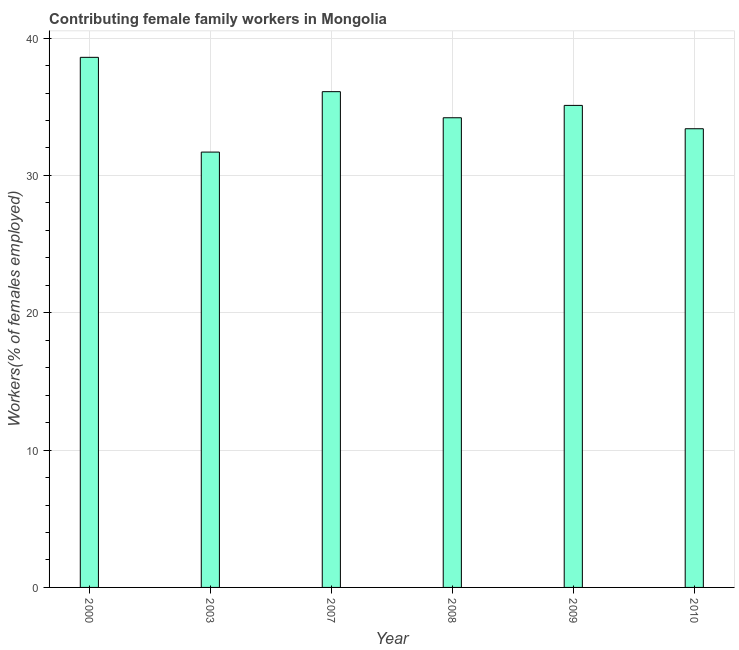Does the graph contain any zero values?
Keep it short and to the point. No. What is the title of the graph?
Provide a short and direct response. Contributing female family workers in Mongolia. What is the label or title of the X-axis?
Give a very brief answer. Year. What is the label or title of the Y-axis?
Make the answer very short. Workers(% of females employed). What is the contributing female family workers in 2007?
Your response must be concise. 36.1. Across all years, what is the maximum contributing female family workers?
Your answer should be compact. 38.6. Across all years, what is the minimum contributing female family workers?
Make the answer very short. 31.7. In which year was the contributing female family workers minimum?
Make the answer very short. 2003. What is the sum of the contributing female family workers?
Ensure brevity in your answer.  209.1. What is the difference between the contributing female family workers in 2003 and 2007?
Provide a succinct answer. -4.4. What is the average contributing female family workers per year?
Provide a short and direct response. 34.85. What is the median contributing female family workers?
Your answer should be very brief. 34.65. In how many years, is the contributing female family workers greater than 20 %?
Provide a short and direct response. 6. Is the difference between the contributing female family workers in 2000 and 2008 greater than the difference between any two years?
Your response must be concise. No. Is the sum of the contributing female family workers in 2003 and 2009 greater than the maximum contributing female family workers across all years?
Make the answer very short. Yes. What is the difference between the highest and the lowest contributing female family workers?
Offer a very short reply. 6.9. Are all the bars in the graph horizontal?
Ensure brevity in your answer.  No. Are the values on the major ticks of Y-axis written in scientific E-notation?
Provide a succinct answer. No. What is the Workers(% of females employed) of 2000?
Make the answer very short. 38.6. What is the Workers(% of females employed) in 2003?
Make the answer very short. 31.7. What is the Workers(% of females employed) of 2007?
Your response must be concise. 36.1. What is the Workers(% of females employed) of 2008?
Offer a very short reply. 34.2. What is the Workers(% of females employed) in 2009?
Your response must be concise. 35.1. What is the Workers(% of females employed) of 2010?
Your response must be concise. 33.4. What is the difference between the Workers(% of females employed) in 2000 and 2009?
Keep it short and to the point. 3.5. What is the difference between the Workers(% of females employed) in 2003 and 2008?
Give a very brief answer. -2.5. What is the difference between the Workers(% of females employed) in 2003 and 2009?
Offer a very short reply. -3.4. What is the difference between the Workers(% of females employed) in 2007 and 2008?
Ensure brevity in your answer.  1.9. What is the difference between the Workers(% of females employed) in 2007 and 2010?
Keep it short and to the point. 2.7. What is the ratio of the Workers(% of females employed) in 2000 to that in 2003?
Provide a short and direct response. 1.22. What is the ratio of the Workers(% of females employed) in 2000 to that in 2007?
Ensure brevity in your answer.  1.07. What is the ratio of the Workers(% of females employed) in 2000 to that in 2008?
Make the answer very short. 1.13. What is the ratio of the Workers(% of females employed) in 2000 to that in 2010?
Your response must be concise. 1.16. What is the ratio of the Workers(% of females employed) in 2003 to that in 2007?
Provide a short and direct response. 0.88. What is the ratio of the Workers(% of females employed) in 2003 to that in 2008?
Make the answer very short. 0.93. What is the ratio of the Workers(% of females employed) in 2003 to that in 2009?
Offer a terse response. 0.9. What is the ratio of the Workers(% of females employed) in 2003 to that in 2010?
Your answer should be compact. 0.95. What is the ratio of the Workers(% of females employed) in 2007 to that in 2008?
Your answer should be compact. 1.06. What is the ratio of the Workers(% of females employed) in 2007 to that in 2009?
Provide a succinct answer. 1.03. What is the ratio of the Workers(% of females employed) in 2007 to that in 2010?
Offer a very short reply. 1.08. What is the ratio of the Workers(% of females employed) in 2008 to that in 2009?
Offer a terse response. 0.97. What is the ratio of the Workers(% of females employed) in 2008 to that in 2010?
Provide a short and direct response. 1.02. What is the ratio of the Workers(% of females employed) in 2009 to that in 2010?
Offer a terse response. 1.05. 